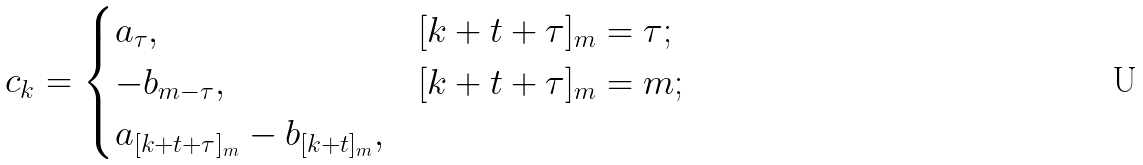<formula> <loc_0><loc_0><loc_500><loc_500>c _ { k } = \begin{cases} a _ { \tau } , & [ k + t + \tau ] _ { m } = \tau ; \\ - b _ { m - \tau } , & [ k + t + \tau ] _ { m } = m ; \\ a _ { [ k + t + \tau ] _ { m } } - b _ { [ k + t ] _ { m } } , & \end{cases}</formula> 